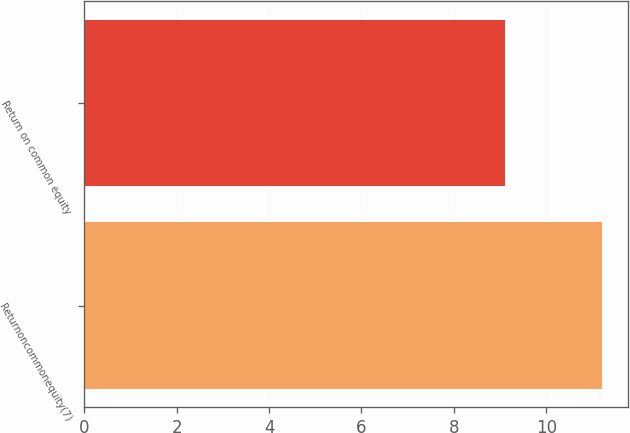<chart> <loc_0><loc_0><loc_500><loc_500><bar_chart><fcel>Returnoncommonequity(7)<fcel>Return on common equity<nl><fcel>11.2<fcel>9.1<nl></chart> 